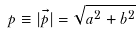Convert formula to latex. <formula><loc_0><loc_0><loc_500><loc_500>p \equiv | \vec { p } | = \sqrt { a ^ { 2 } + b ^ { 2 } }</formula> 